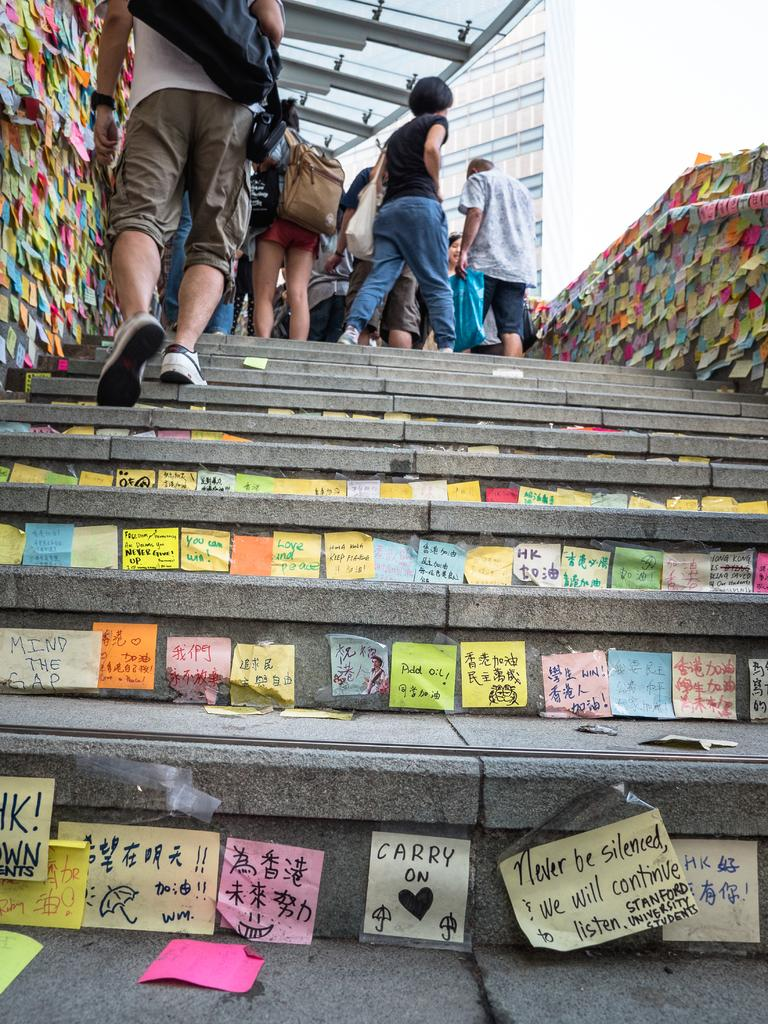Provide a one-sentence caption for the provided image. A sticky note that says carry on is stuck to the riser of a stone staircase. 